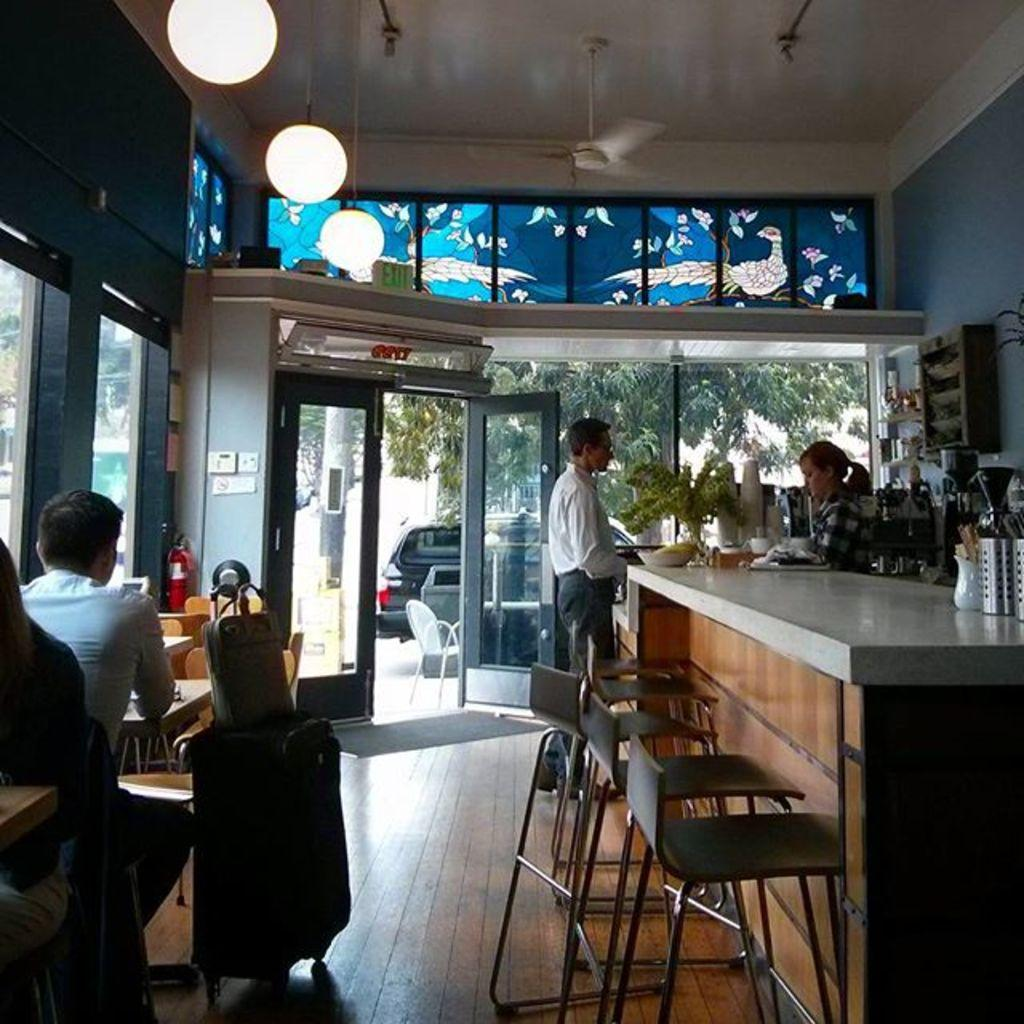What is the general activity of the people in the image? There are people standing in the image, which suggests they might be waiting or observing something. What is the position of the man in the image? There is a man sitting on a chair in the image. What object is beside the man in the image? There is a luggage bag beside the man in the image. How many rabbits can be seen in the image? There are no rabbits present in the image. What is the political stance of the governor in the image? There is no governor present in the image, so it is not possible to determine their political stance. 